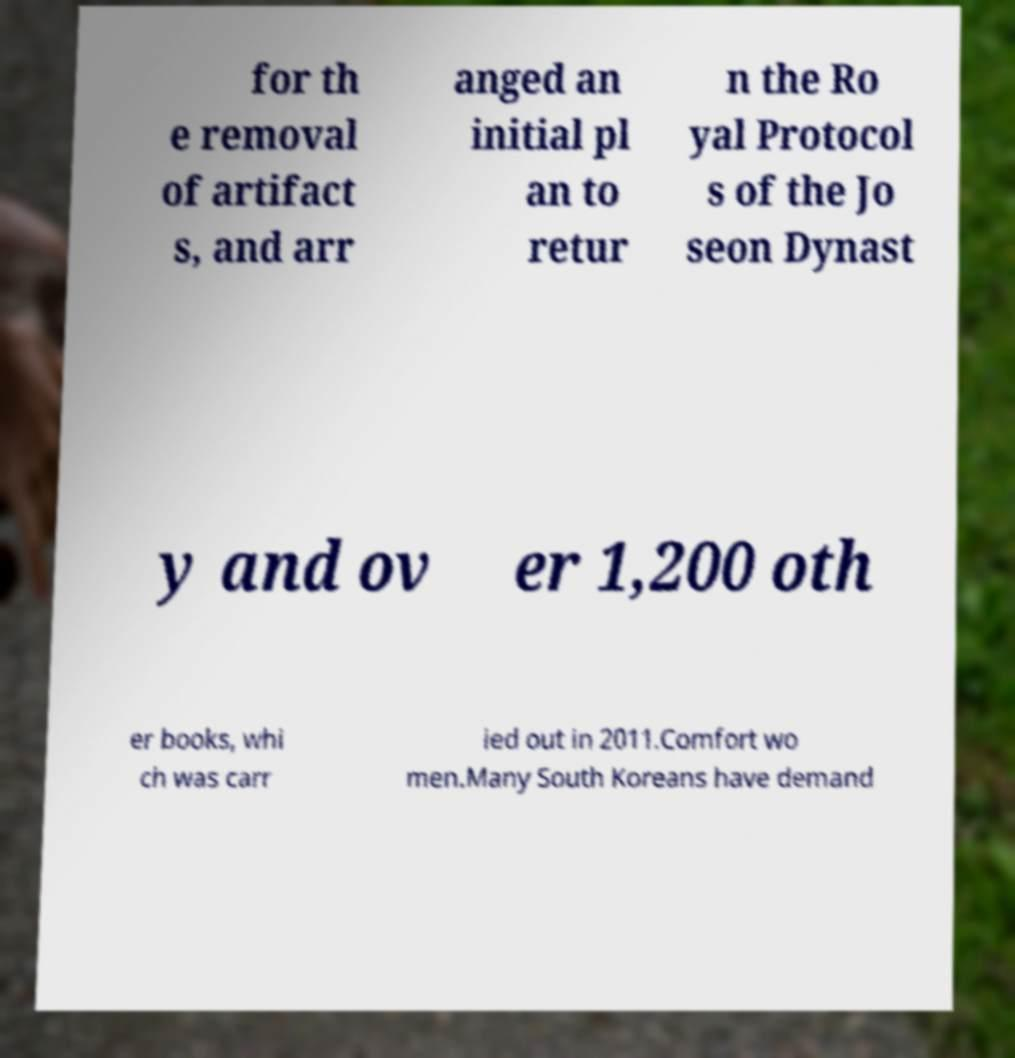What messages or text are displayed in this image? I need them in a readable, typed format. for th e removal of artifact s, and arr anged an initial pl an to retur n the Ro yal Protocol s of the Jo seon Dynast y and ov er 1,200 oth er books, whi ch was carr ied out in 2011.Comfort wo men.Many South Koreans have demand 